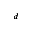Convert formula to latex. <formula><loc_0><loc_0><loc_500><loc_500>^ { d }</formula> 